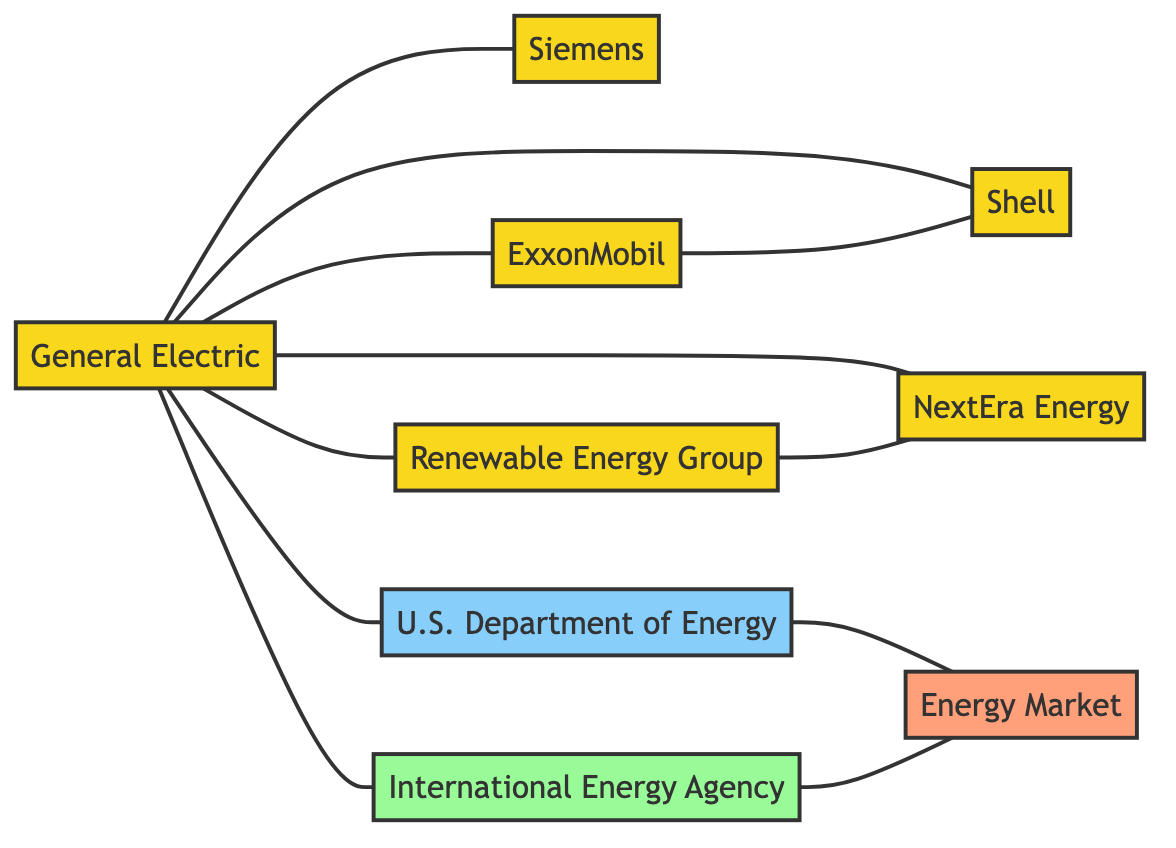What is the total number of nodes in the diagram? The nodes are: General Electric, Siemens, ExxonMobil, Shell, Renewable Energy Group, NextEra Energy, U.S. Department of Energy, International Energy Agency, and Energy Market. Counting these nodes gives a total of 9.
Answer: 9 What type of relationship exists between General Electric and Siemens? The edge between General Electric and Siemens indicates a "Competitor" relationship, which is denoted clearly on the diagram.
Answer: Competitor Which companies have a strategic partnership with General Electric? General Electric has strategic partnerships with ExxonMobil and Shell. This information is gathered from the edges connecting General Electric to these companies labeled "Strategic Partner."
Answer: ExxonMobil, Shell How many competitors does Renewable Energy Group have? Renewable Energy Group is connected to NextEra Energy through an edge labeled "Competitor." It implies that it has 1 competitor.
Answer: 1 What is the relationship between the U.S. Department of Energy and the Energy Market? The U.S. Department of Energy regulates the Energy Market as indicated by the "Regulates" label on the connecting edge.
Answer: Regulates Which companies are collaborators with General Electric? General Electric collaborates with Renewable Energy Group and NextEra Energy based on the edges marked "Collaborator."
Answer: Renewable Energy Group, NextEra Energy What type of organization is the International Energy Agency? The International Energy Agency is categorized as an "Organization" in the diagram. This is stated next to its representation on the diagram.
Answer: Organization What role does the U.S. Department of Energy have in the energy market? The U.S. Department of Energy regulates the Energy Market, as shown by the relationship specified in the edge.
Answer: Regulates How many edges are there in total connecting nodes in the diagram? The edges between nodes include relationships like partnerships, collaborations, and regulations. Counting all these connections shows a total of 10 edges.
Answer: 10 